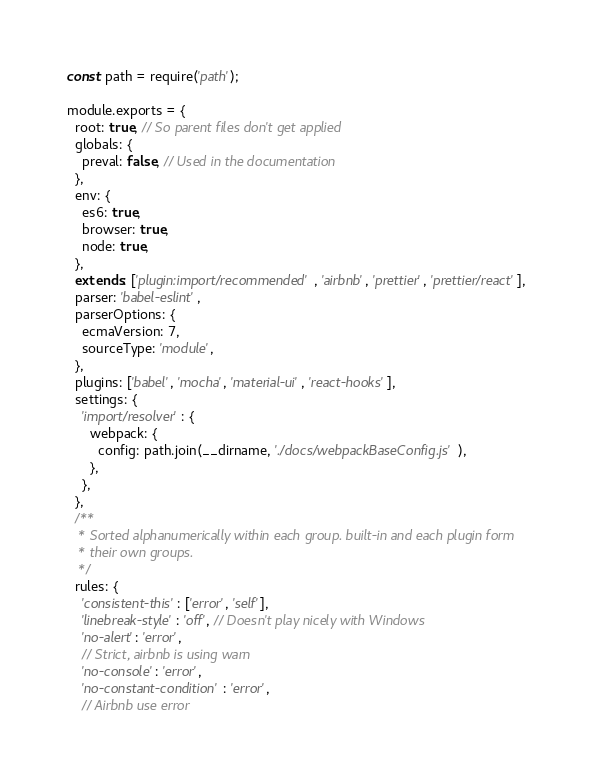Convert code to text. <code><loc_0><loc_0><loc_500><loc_500><_JavaScript_>const path = require('path');

module.exports = {
  root: true, // So parent files don't get applied
  globals: {
    preval: false, // Used in the documentation
  },
  env: {
    es6: true,
    browser: true,
    node: true,
  },
  extends: ['plugin:import/recommended', 'airbnb', 'prettier', 'prettier/react'],
  parser: 'babel-eslint',
  parserOptions: {
    ecmaVersion: 7,
    sourceType: 'module',
  },
  plugins: ['babel', 'mocha', 'material-ui', 'react-hooks'],
  settings: {
    'import/resolver': {
      webpack: {
        config: path.join(__dirname, './docs/webpackBaseConfig.js'),
      },
    },
  },
  /**
   * Sorted alphanumerically within each group. built-in and each plugin form
   * their own groups.
   */
  rules: {
    'consistent-this': ['error', 'self'],
    'linebreak-style': 'off', // Doesn't play nicely with Windows
    'no-alert': 'error',
    // Strict, airbnb is using warn
    'no-console': 'error',
    'no-constant-condition': 'error',
    // Airbnb use error</code> 